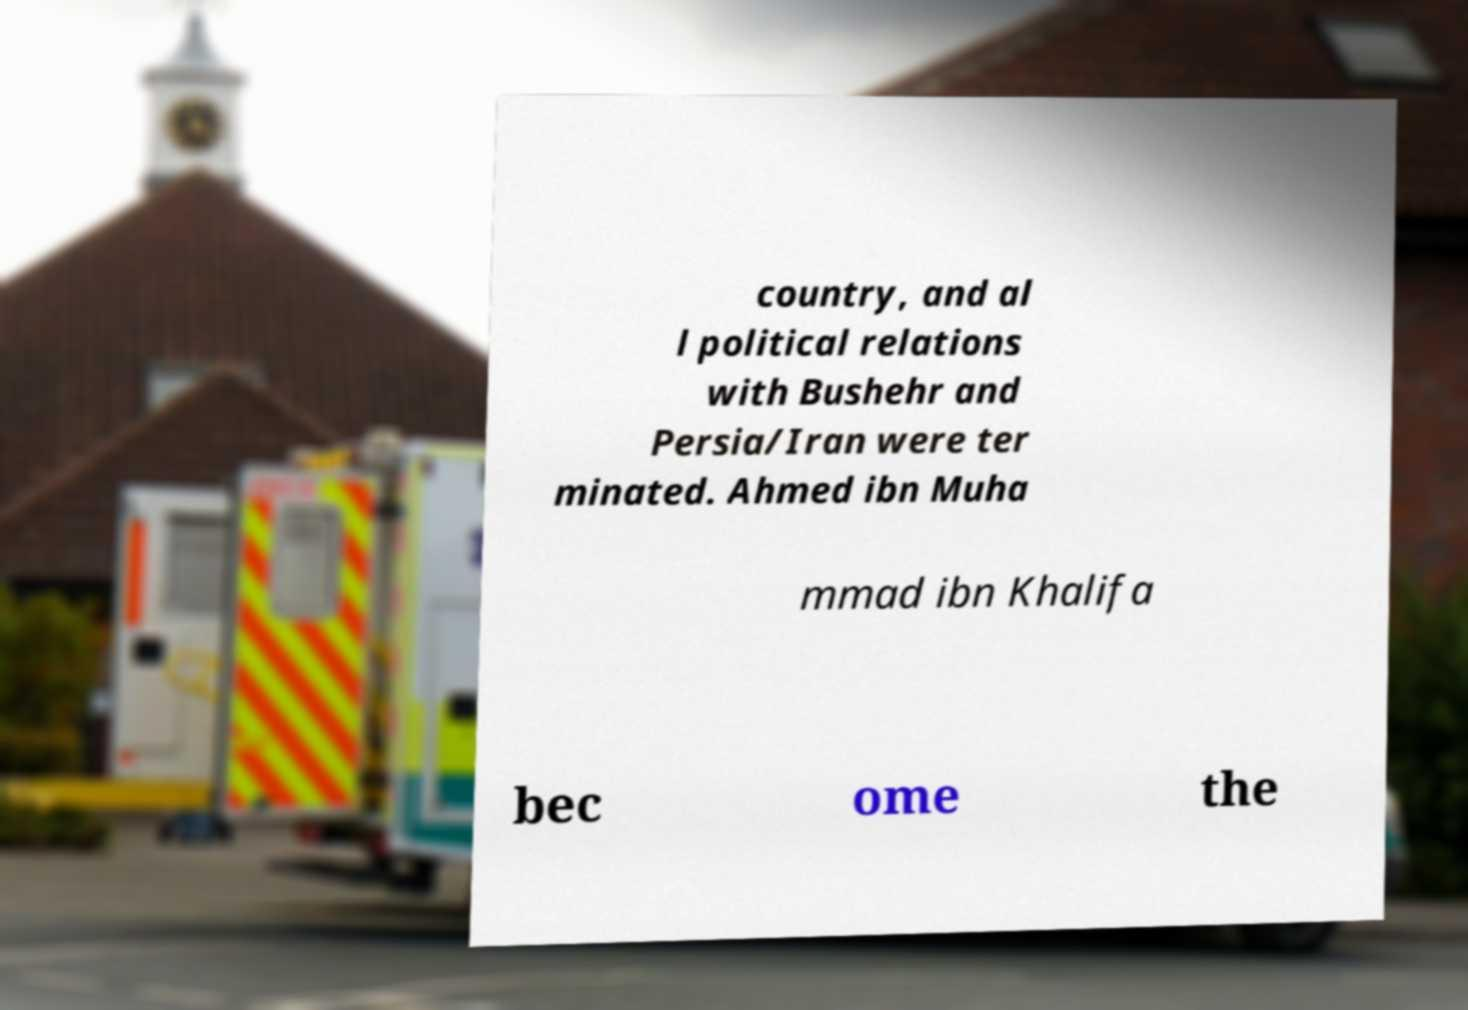Can you read and provide the text displayed in the image?This photo seems to have some interesting text. Can you extract and type it out for me? country, and al l political relations with Bushehr and Persia/Iran were ter minated. Ahmed ibn Muha mmad ibn Khalifa bec ome the 